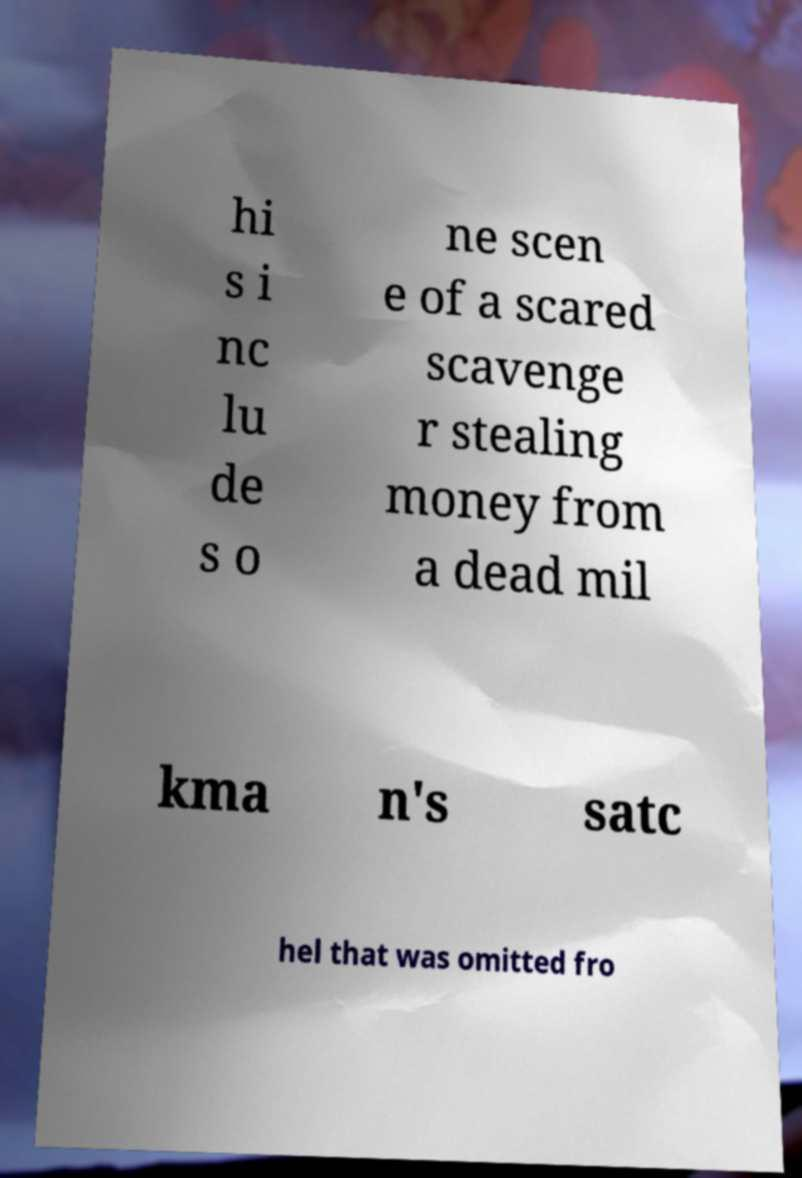For documentation purposes, I need the text within this image transcribed. Could you provide that? hi s i nc lu de s o ne scen e of a scared scavenge r stealing money from a dead mil kma n's satc hel that was omitted fro 